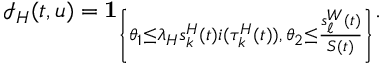Convert formula to latex. <formula><loc_0><loc_0><loc_500><loc_500>\mathcal { I } _ { H } ( t , u ) = 1 _ { \left \{ \theta _ { 1 } \leq \lambda _ { H } s _ { k } ^ { H } ( t ) i ( \tau _ { k } ^ { H } ( t ) ) , \, \theta _ { 2 } \leq \frac { s _ { \ell } ^ { W } ( t ) } { S ( t ) } \right \} } .</formula> 